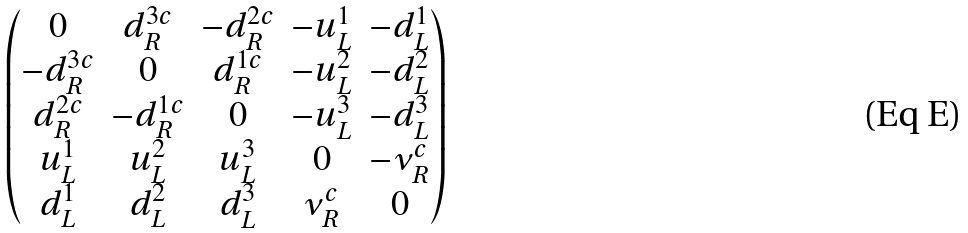<formula> <loc_0><loc_0><loc_500><loc_500>\begin{pmatrix} 0 & d _ { R } ^ { 3 c } & - d _ { R } ^ { 2 c } & - u _ { L } ^ { 1 } & - d _ { L } ^ { 1 } \\ - d _ { R } ^ { 3 c } & 0 & d _ { R } ^ { 1 c } & - u _ { L } ^ { 2 } & - d _ { L } ^ { 2 } \\ d _ { R } ^ { 2 c } & - d _ { R } ^ { 1 c } & 0 & - u _ { L } ^ { 3 } & - d _ { L } ^ { 3 } \\ u _ { L } ^ { 1 } & u _ { L } ^ { 2 } & u _ { L } ^ { 3 } & 0 & - \nu _ { R } ^ { c } \\ d _ { L } ^ { 1 } & d _ { L } ^ { 2 } & d _ { L } ^ { 3 } & \nu _ { R } ^ { c } & 0 \\ \end{pmatrix}</formula> 